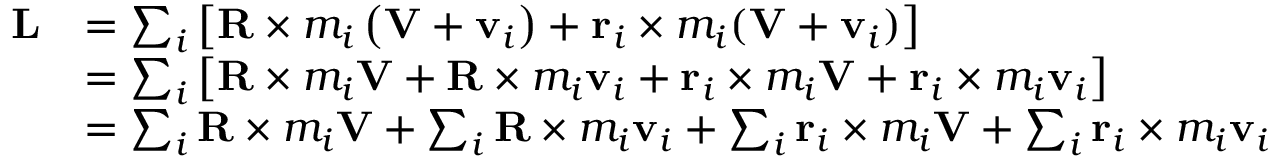<formula> <loc_0><loc_0><loc_500><loc_500>{ \begin{array} { r l } { L } & { = \sum _ { i } \left [ R \times m _ { i } \left ( V + v _ { i } \right ) + r _ { i } \times m _ { i } ( V + v _ { i } ) \right ] } \\ & { = \sum _ { i } \left [ R \times m _ { i } V + R \times m _ { i } v _ { i } + r _ { i } \times m _ { i } V + r _ { i } \times m _ { i } v _ { i } \right ] } \\ & { = \sum _ { i } R \times m _ { i } V + \sum _ { i } R \times m _ { i } v _ { i } + \sum _ { i } r _ { i } \times m _ { i } V + \sum _ { i } r _ { i } \times m _ { i } v _ { i } } \end{array} }</formula> 